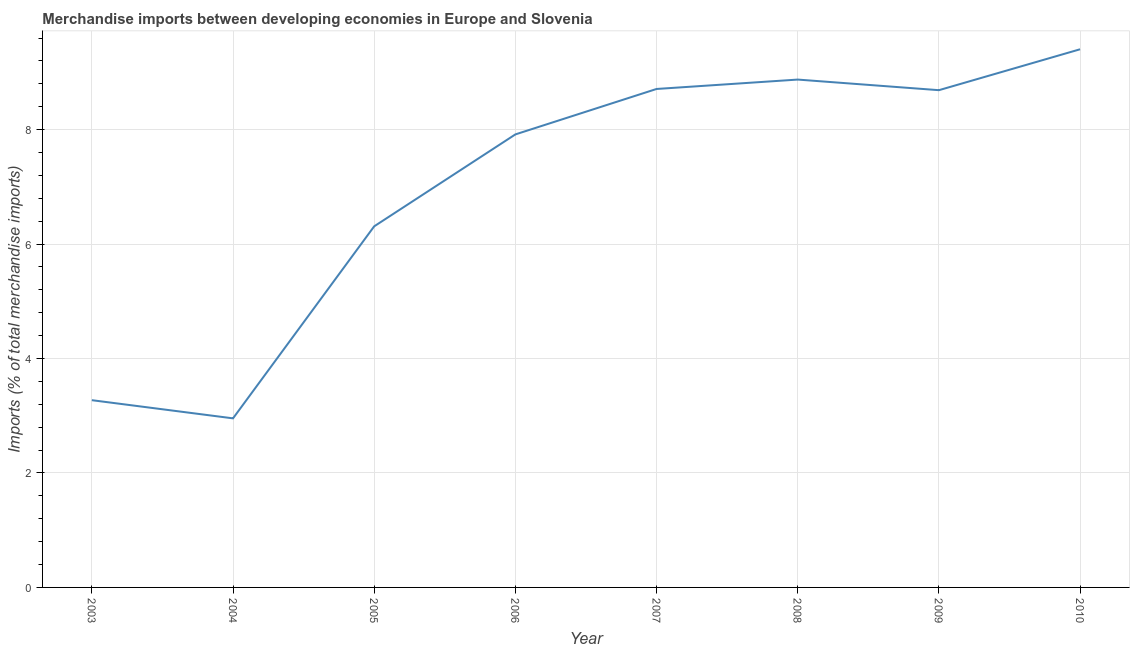What is the merchandise imports in 2003?
Your response must be concise. 3.27. Across all years, what is the maximum merchandise imports?
Your response must be concise. 9.4. Across all years, what is the minimum merchandise imports?
Your response must be concise. 2.95. In which year was the merchandise imports minimum?
Your answer should be very brief. 2004. What is the sum of the merchandise imports?
Keep it short and to the point. 56.13. What is the difference between the merchandise imports in 2004 and 2005?
Make the answer very short. -3.36. What is the average merchandise imports per year?
Keep it short and to the point. 7.02. What is the median merchandise imports?
Make the answer very short. 8.3. What is the ratio of the merchandise imports in 2005 to that in 2008?
Keep it short and to the point. 0.71. Is the merchandise imports in 2003 less than that in 2004?
Give a very brief answer. No. What is the difference between the highest and the second highest merchandise imports?
Your answer should be very brief. 0.53. Is the sum of the merchandise imports in 2004 and 2010 greater than the maximum merchandise imports across all years?
Keep it short and to the point. Yes. What is the difference between the highest and the lowest merchandise imports?
Your answer should be very brief. 6.45. How many years are there in the graph?
Provide a short and direct response. 8. Does the graph contain grids?
Provide a short and direct response. Yes. What is the title of the graph?
Offer a very short reply. Merchandise imports between developing economies in Europe and Slovenia. What is the label or title of the X-axis?
Give a very brief answer. Year. What is the label or title of the Y-axis?
Offer a very short reply. Imports (% of total merchandise imports). What is the Imports (% of total merchandise imports) in 2003?
Give a very brief answer. 3.27. What is the Imports (% of total merchandise imports) of 2004?
Provide a succinct answer. 2.95. What is the Imports (% of total merchandise imports) in 2005?
Provide a short and direct response. 6.31. What is the Imports (% of total merchandise imports) in 2006?
Ensure brevity in your answer.  7.92. What is the Imports (% of total merchandise imports) of 2007?
Your response must be concise. 8.71. What is the Imports (% of total merchandise imports) of 2008?
Offer a terse response. 8.88. What is the Imports (% of total merchandise imports) of 2009?
Ensure brevity in your answer.  8.69. What is the Imports (% of total merchandise imports) in 2010?
Offer a terse response. 9.4. What is the difference between the Imports (% of total merchandise imports) in 2003 and 2004?
Your answer should be very brief. 0.32. What is the difference between the Imports (% of total merchandise imports) in 2003 and 2005?
Your answer should be very brief. -3.04. What is the difference between the Imports (% of total merchandise imports) in 2003 and 2006?
Provide a short and direct response. -4.64. What is the difference between the Imports (% of total merchandise imports) in 2003 and 2007?
Your response must be concise. -5.44. What is the difference between the Imports (% of total merchandise imports) in 2003 and 2008?
Give a very brief answer. -5.6. What is the difference between the Imports (% of total merchandise imports) in 2003 and 2009?
Give a very brief answer. -5.42. What is the difference between the Imports (% of total merchandise imports) in 2003 and 2010?
Offer a terse response. -6.13. What is the difference between the Imports (% of total merchandise imports) in 2004 and 2005?
Your response must be concise. -3.36. What is the difference between the Imports (% of total merchandise imports) in 2004 and 2006?
Your answer should be compact. -4.96. What is the difference between the Imports (% of total merchandise imports) in 2004 and 2007?
Your answer should be very brief. -5.76. What is the difference between the Imports (% of total merchandise imports) in 2004 and 2008?
Make the answer very short. -5.92. What is the difference between the Imports (% of total merchandise imports) in 2004 and 2009?
Keep it short and to the point. -5.74. What is the difference between the Imports (% of total merchandise imports) in 2004 and 2010?
Ensure brevity in your answer.  -6.45. What is the difference between the Imports (% of total merchandise imports) in 2005 and 2006?
Make the answer very short. -1.61. What is the difference between the Imports (% of total merchandise imports) in 2005 and 2007?
Your response must be concise. -2.4. What is the difference between the Imports (% of total merchandise imports) in 2005 and 2008?
Provide a short and direct response. -2.56. What is the difference between the Imports (% of total merchandise imports) in 2005 and 2009?
Offer a terse response. -2.38. What is the difference between the Imports (% of total merchandise imports) in 2005 and 2010?
Provide a succinct answer. -3.09. What is the difference between the Imports (% of total merchandise imports) in 2006 and 2007?
Make the answer very short. -0.79. What is the difference between the Imports (% of total merchandise imports) in 2006 and 2008?
Your answer should be compact. -0.96. What is the difference between the Imports (% of total merchandise imports) in 2006 and 2009?
Your answer should be compact. -0.77. What is the difference between the Imports (% of total merchandise imports) in 2006 and 2010?
Keep it short and to the point. -1.49. What is the difference between the Imports (% of total merchandise imports) in 2007 and 2008?
Ensure brevity in your answer.  -0.16. What is the difference between the Imports (% of total merchandise imports) in 2007 and 2009?
Offer a terse response. 0.02. What is the difference between the Imports (% of total merchandise imports) in 2007 and 2010?
Give a very brief answer. -0.69. What is the difference between the Imports (% of total merchandise imports) in 2008 and 2009?
Provide a succinct answer. 0.19. What is the difference between the Imports (% of total merchandise imports) in 2008 and 2010?
Ensure brevity in your answer.  -0.53. What is the difference between the Imports (% of total merchandise imports) in 2009 and 2010?
Ensure brevity in your answer.  -0.71. What is the ratio of the Imports (% of total merchandise imports) in 2003 to that in 2004?
Offer a very short reply. 1.11. What is the ratio of the Imports (% of total merchandise imports) in 2003 to that in 2005?
Provide a succinct answer. 0.52. What is the ratio of the Imports (% of total merchandise imports) in 2003 to that in 2006?
Keep it short and to the point. 0.41. What is the ratio of the Imports (% of total merchandise imports) in 2003 to that in 2007?
Ensure brevity in your answer.  0.38. What is the ratio of the Imports (% of total merchandise imports) in 2003 to that in 2008?
Your response must be concise. 0.37. What is the ratio of the Imports (% of total merchandise imports) in 2003 to that in 2009?
Offer a terse response. 0.38. What is the ratio of the Imports (% of total merchandise imports) in 2003 to that in 2010?
Offer a very short reply. 0.35. What is the ratio of the Imports (% of total merchandise imports) in 2004 to that in 2005?
Offer a very short reply. 0.47. What is the ratio of the Imports (% of total merchandise imports) in 2004 to that in 2006?
Give a very brief answer. 0.37. What is the ratio of the Imports (% of total merchandise imports) in 2004 to that in 2007?
Keep it short and to the point. 0.34. What is the ratio of the Imports (% of total merchandise imports) in 2004 to that in 2008?
Make the answer very short. 0.33. What is the ratio of the Imports (% of total merchandise imports) in 2004 to that in 2009?
Keep it short and to the point. 0.34. What is the ratio of the Imports (% of total merchandise imports) in 2004 to that in 2010?
Provide a succinct answer. 0.31. What is the ratio of the Imports (% of total merchandise imports) in 2005 to that in 2006?
Provide a succinct answer. 0.8. What is the ratio of the Imports (% of total merchandise imports) in 2005 to that in 2007?
Provide a succinct answer. 0.72. What is the ratio of the Imports (% of total merchandise imports) in 2005 to that in 2008?
Provide a short and direct response. 0.71. What is the ratio of the Imports (% of total merchandise imports) in 2005 to that in 2009?
Make the answer very short. 0.73. What is the ratio of the Imports (% of total merchandise imports) in 2005 to that in 2010?
Keep it short and to the point. 0.67. What is the ratio of the Imports (% of total merchandise imports) in 2006 to that in 2007?
Make the answer very short. 0.91. What is the ratio of the Imports (% of total merchandise imports) in 2006 to that in 2008?
Offer a very short reply. 0.89. What is the ratio of the Imports (% of total merchandise imports) in 2006 to that in 2009?
Your answer should be very brief. 0.91. What is the ratio of the Imports (% of total merchandise imports) in 2006 to that in 2010?
Your answer should be very brief. 0.84. What is the ratio of the Imports (% of total merchandise imports) in 2007 to that in 2009?
Ensure brevity in your answer.  1. What is the ratio of the Imports (% of total merchandise imports) in 2007 to that in 2010?
Your answer should be very brief. 0.93. What is the ratio of the Imports (% of total merchandise imports) in 2008 to that in 2010?
Ensure brevity in your answer.  0.94. What is the ratio of the Imports (% of total merchandise imports) in 2009 to that in 2010?
Provide a succinct answer. 0.92. 